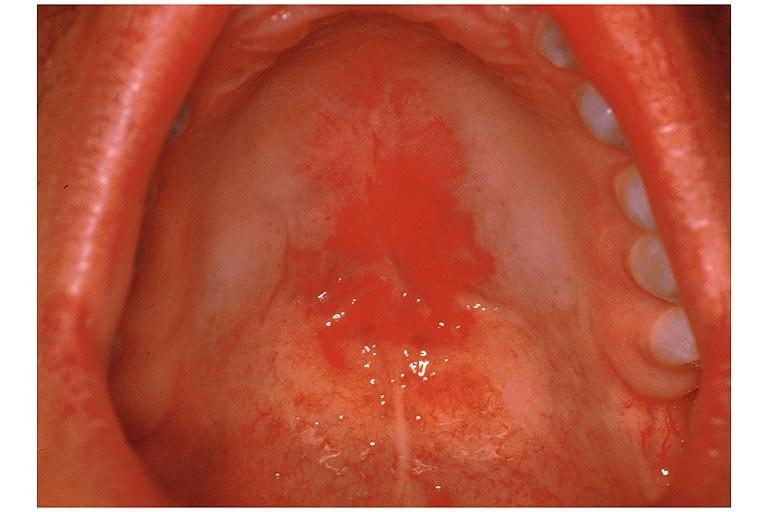where is this?
Answer the question using a single word or phrase. Oral 